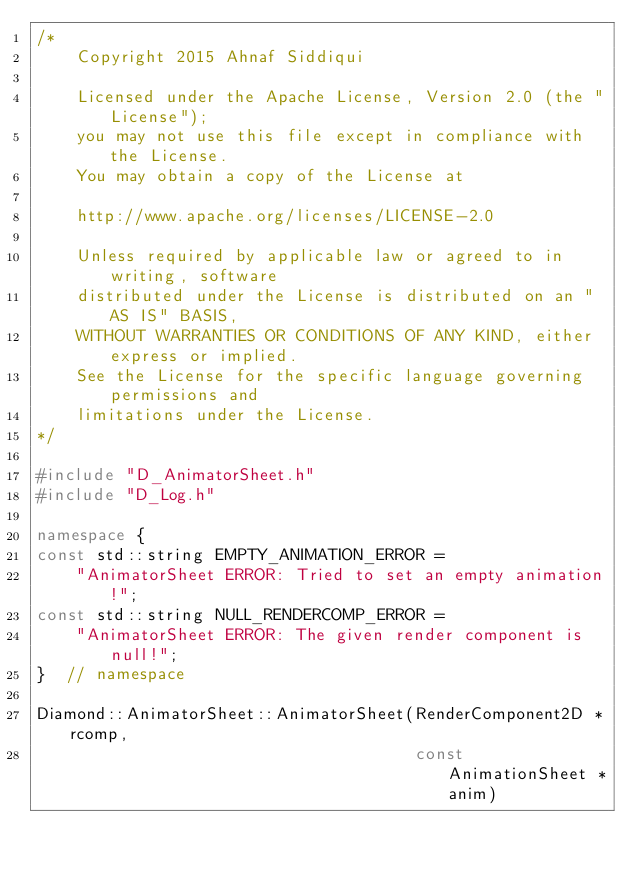<code> <loc_0><loc_0><loc_500><loc_500><_C++_>/*
    Copyright 2015 Ahnaf Siddiqui

    Licensed under the Apache License, Version 2.0 (the "License");
    you may not use this file except in compliance with the License.
    You may obtain a copy of the License at

    http://www.apache.org/licenses/LICENSE-2.0

    Unless required by applicable law or agreed to in writing, software
    distributed under the License is distributed on an "AS IS" BASIS,
    WITHOUT WARRANTIES OR CONDITIONS OF ANY KIND, either express or implied.
    See the License for the specific language governing permissions and
    limitations under the License.
*/

#include "D_AnimatorSheet.h"
#include "D_Log.h"

namespace {
const std::string EMPTY_ANIMATION_ERROR =
    "AnimatorSheet ERROR: Tried to set an empty animation!";
const std::string NULL_RENDERCOMP_ERROR =
    "AnimatorSheet ERROR: The given render component is null!";
}  // namespace

Diamond::AnimatorSheet::AnimatorSheet(RenderComponent2D *rcomp,
                                      const AnimationSheet *anim)</code> 